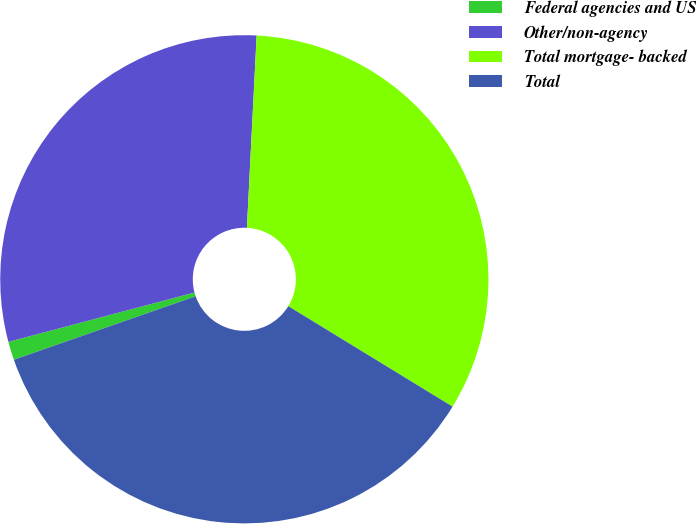<chart> <loc_0><loc_0><loc_500><loc_500><pie_chart><fcel>Federal agencies and US<fcel>Other/non-agency<fcel>Total mortgage- backed<fcel>Total<nl><fcel>1.22%<fcel>29.93%<fcel>32.93%<fcel>35.92%<nl></chart> 